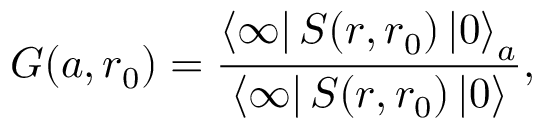Convert formula to latex. <formula><loc_0><loc_0><loc_500><loc_500>G ( a , r _ { 0 } ) = \frac { \left \langle \infty \right | S ( r , r _ { 0 } ) \left | 0 \right \rangle _ { a } } { \left \langle \infty \right | S ( r , r _ { 0 } ) \left | 0 \right \rangle } ,</formula> 